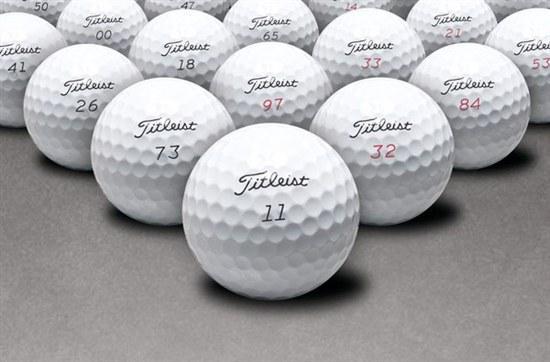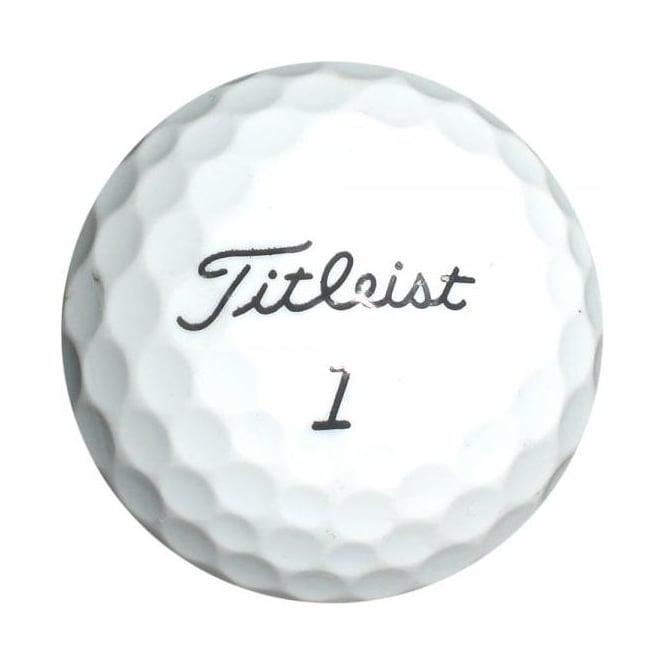The first image is the image on the left, the second image is the image on the right. Evaluate the accuracy of this statement regarding the images: "Only one golf ball is depicted on at least one image.". Is it true? Answer yes or no. Yes. The first image is the image on the left, the second image is the image on the right. Evaluate the accuracy of this statement regarding the images: "At least one image has exactly one golf ball.". Is it true? Answer yes or no. Yes. 